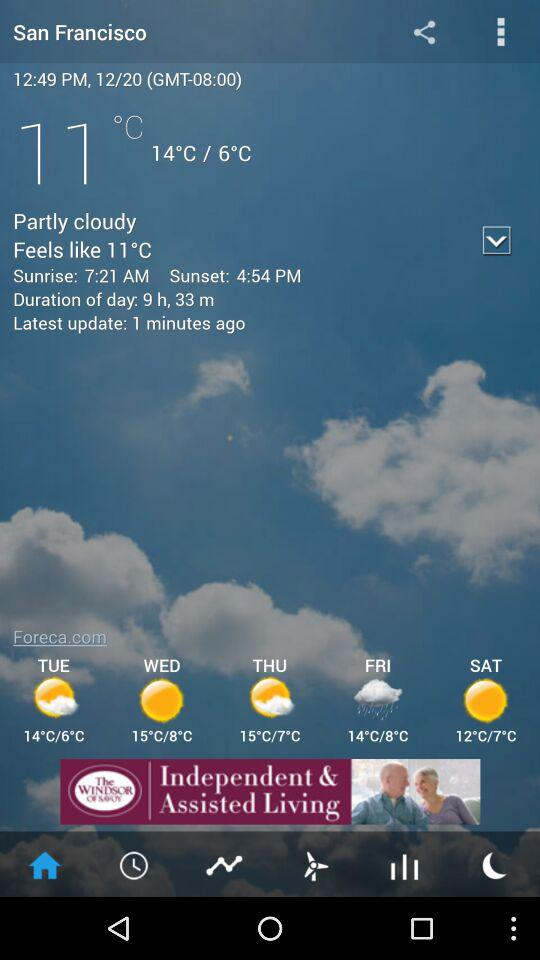What time does the sun rise? The sun rises at 7:21 a.m. 